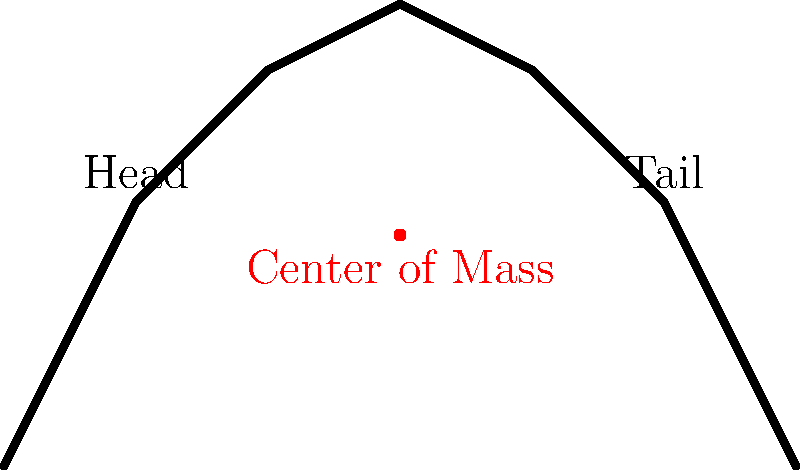In a dinosaur skeleton model, the center of mass is crucial for proper mounting and display. If the center of mass of a T-Rex skeleton model is located at coordinates (60 cm, 35 cm) relative to a reference point at the base of the tail, what would happen if the support stand was placed directly under the middle of the skeleton at x = 60 cm? To determine what would happen if the support stand was placed at x = 60 cm, we need to consider the relationship between the center of mass and the point of support:

1. The center of mass is located at (60 cm, 35 cm).
2. The proposed support point is at x = 60 cm, which is directly below the center of mass.

3. In a balanced system, the support point should be directly under the center of mass to prevent rotation.

4. Since the x-coordinate of the support (60 cm) matches the x-coordinate of the center of mass (60 cm), the skeleton would be balanced in the horizontal direction.

5. The y-coordinate of the center of mass (35 cm) is above the base, which is typical for a stable upright position.

6. With the support at x = 60 cm, the weight of the skeleton would be evenly distributed on both sides of the support point.

7. This configuration would result in a stable equilibrium, where the skeleton would remain upright and balanced.

Therefore, placing the support stand at x = 60 cm would provide a stable and balanced mounting for the T-Rex skeleton model.
Answer: The skeleton would be stable and balanced. 